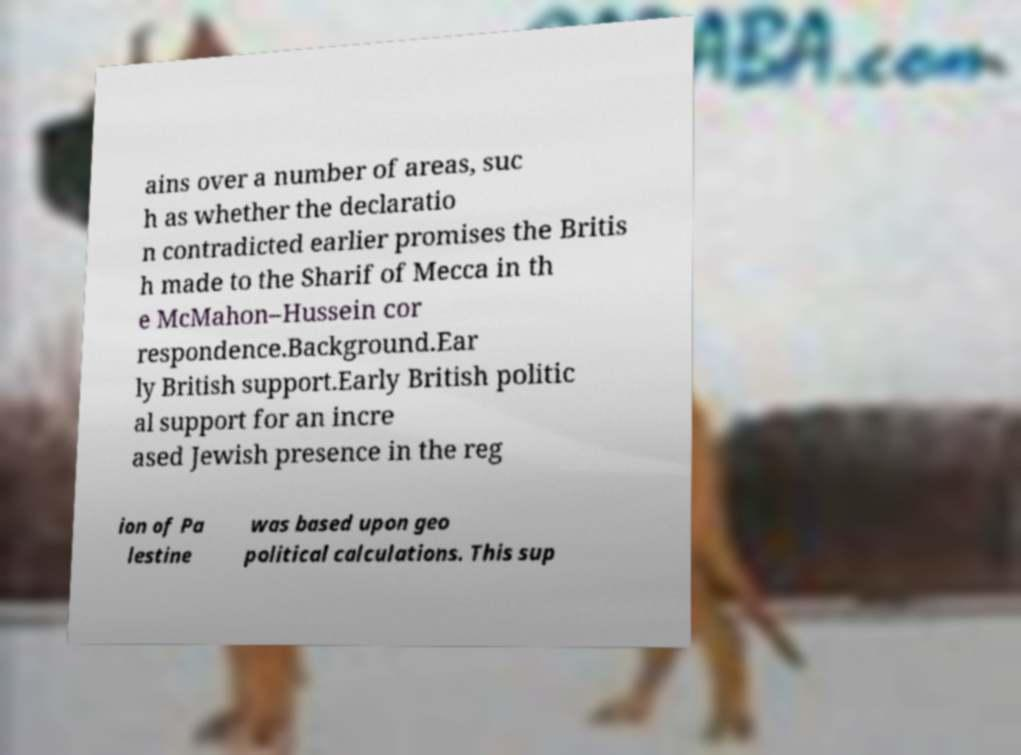I need the written content from this picture converted into text. Can you do that? ains over a number of areas, suc h as whether the declaratio n contradicted earlier promises the Britis h made to the Sharif of Mecca in th e McMahon–Hussein cor respondence.Background.Ear ly British support.Early British politic al support for an incre ased Jewish presence in the reg ion of Pa lestine was based upon geo political calculations. This sup 